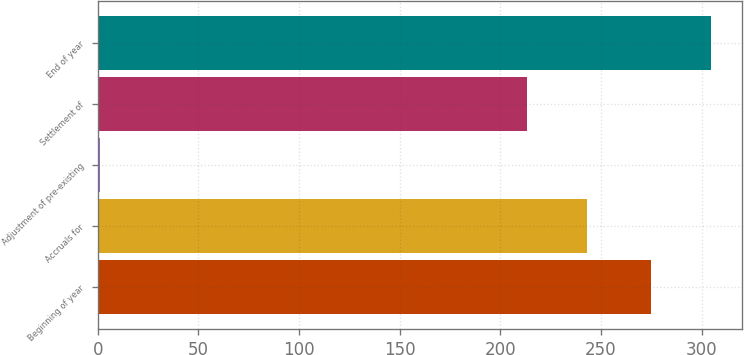Convert chart. <chart><loc_0><loc_0><loc_500><loc_500><bar_chart><fcel>Beginning of year<fcel>Accruals for<fcel>Adjustment of pre-existing<fcel>Settlement of<fcel>End of year<nl><fcel>275<fcel>242.8<fcel>1<fcel>213<fcel>304.8<nl></chart> 